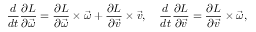<formula> <loc_0><loc_0><loc_500><loc_500>{ \frac { d } { d t } } { \frac { \partial L } { \partial { \vec { \omega } } } } = { \frac { \partial L } { \partial { \vec { \omega } } } } \times { \vec { \omega } } + { \frac { \partial L } { \partial { \vec { v } } } } \times { \vec { v } } , \quad \frac { d } { d t } { \frac { \partial L } { \partial { \vec { v } } } } = { \frac { \partial L } { \partial { \vec { v } } } } \times { \vec { \omega } } ,</formula> 